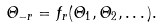Convert formula to latex. <formula><loc_0><loc_0><loc_500><loc_500>\varTheta _ { - r } = f _ { r } ( \varTheta _ { 1 } , \varTheta _ { 2 } , \dots ) .</formula> 